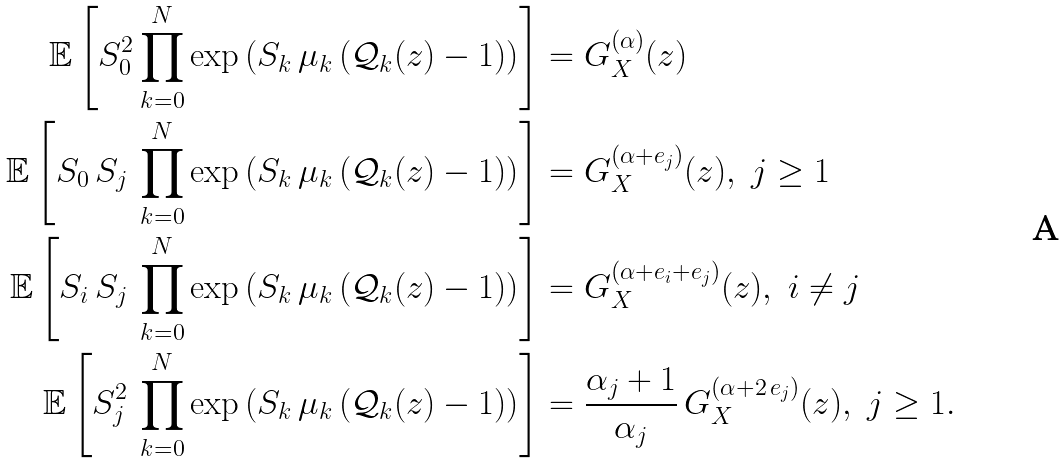Convert formula to latex. <formula><loc_0><loc_0><loc_500><loc_500>\mathbb { E } \left [ S _ { 0 } ^ { 2 } \prod _ { k = 0 } ^ { N } \exp \left ( S _ { k } \, \mu _ { k } \, ( \mathcal { Q } _ { k } ( z ) - 1 ) \right ) \right ] & = G ^ { ( \alpha ) } _ { X } ( z ) \\ \mathbb { E } \left [ S _ { 0 } \, S _ { j } \, \prod _ { k = 0 } ^ { N } \exp \left ( S _ { k } \, \mu _ { k } \, ( \mathcal { Q } _ { k } ( z ) - 1 ) \right ) \right ] & = G ^ { ( \alpha + e _ { j } ) } _ { X } ( z ) , \ j \geq 1 \\ \mathbb { E } \left [ S _ { i } \, S _ { j } \, \prod _ { k = 0 } ^ { N } \exp \left ( S _ { k } \, \mu _ { k } \, ( \mathcal { Q } _ { k } ( z ) - 1 ) \right ) \right ] & = G ^ { ( \alpha + e _ { i } + e _ { j } ) } _ { X } ( z ) , \ i \not = j \\ \mathbb { E } \left [ S _ { j } ^ { 2 } \, \prod _ { k = 0 } ^ { N } \exp \left ( S _ { k } \, \mu _ { k } \, ( \mathcal { Q } _ { k } ( z ) - 1 ) \right ) \right ] & = \frac { \alpha _ { j } + 1 } { \alpha _ { j } } \, G ^ { ( \alpha + 2 \, e _ { j } ) } _ { X } ( z ) , \ j \geq 1 .</formula> 